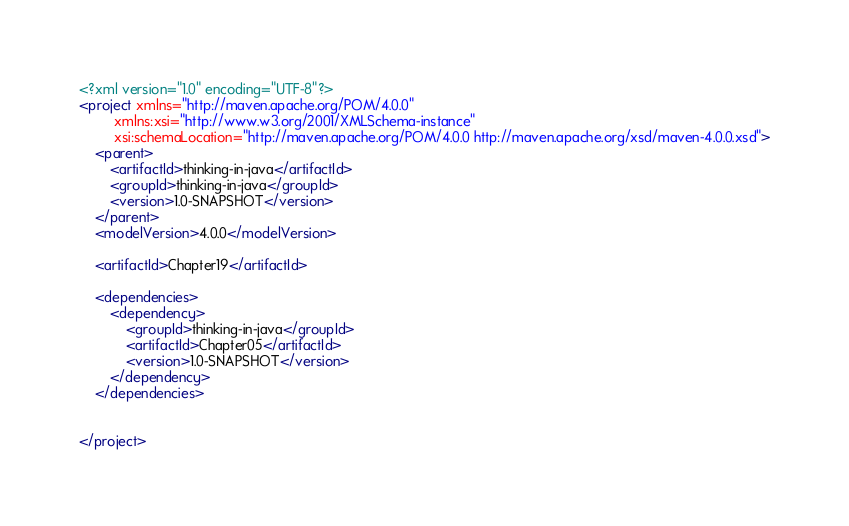Convert code to text. <code><loc_0><loc_0><loc_500><loc_500><_XML_><?xml version="1.0" encoding="UTF-8"?>
<project xmlns="http://maven.apache.org/POM/4.0.0"
         xmlns:xsi="http://www.w3.org/2001/XMLSchema-instance"
         xsi:schemaLocation="http://maven.apache.org/POM/4.0.0 http://maven.apache.org/xsd/maven-4.0.0.xsd">
    <parent>
        <artifactId>thinking-in-java</artifactId>
        <groupId>thinking-in-java</groupId>
        <version>1.0-SNAPSHOT</version>
    </parent>
    <modelVersion>4.0.0</modelVersion>

    <artifactId>Chapter19</artifactId>

    <dependencies>
        <dependency>
            <groupId>thinking-in-java</groupId>
            <artifactId>Chapter05</artifactId>
            <version>1.0-SNAPSHOT</version>
        </dependency>
    </dependencies>


</project>
</code> 